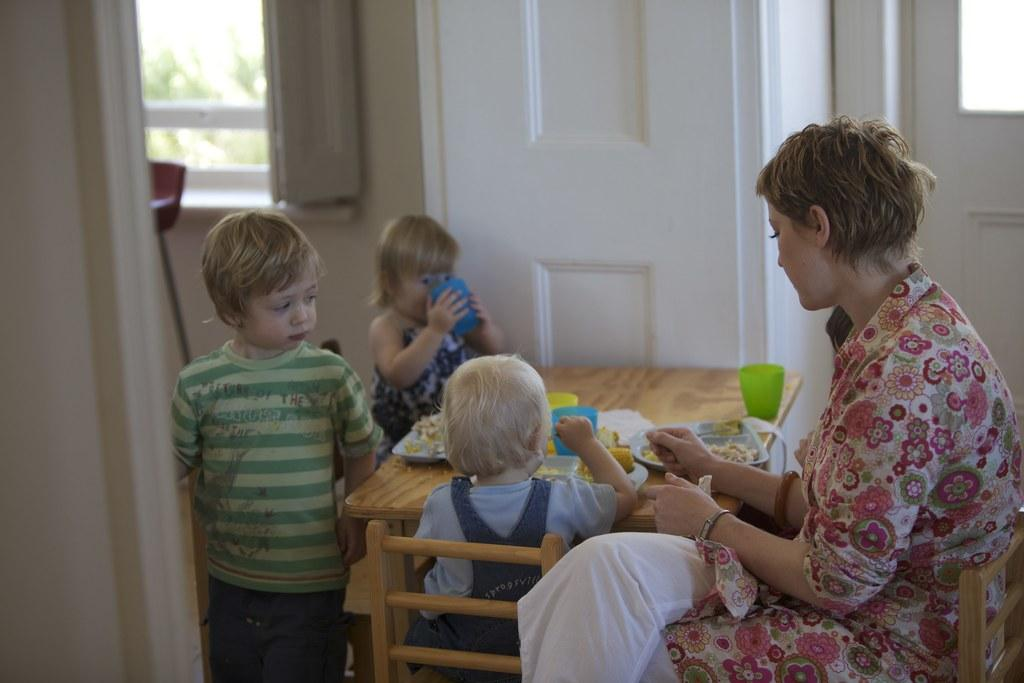What is the woman doing in the image? The woman is sitting on a chair in the image. What are the three kids doing in the image? The three kids are at a table in the image. What can be found on the table with the kids? There are food items and cups on the table. What can be seen in the background of the image? In the background, there is a window, a wall, and doors. What type of fiction is the woman reading to the kids in the image? There is no book or reading material visible in the image, so it cannot be determined if the woman is reading fiction or any other type of content. 